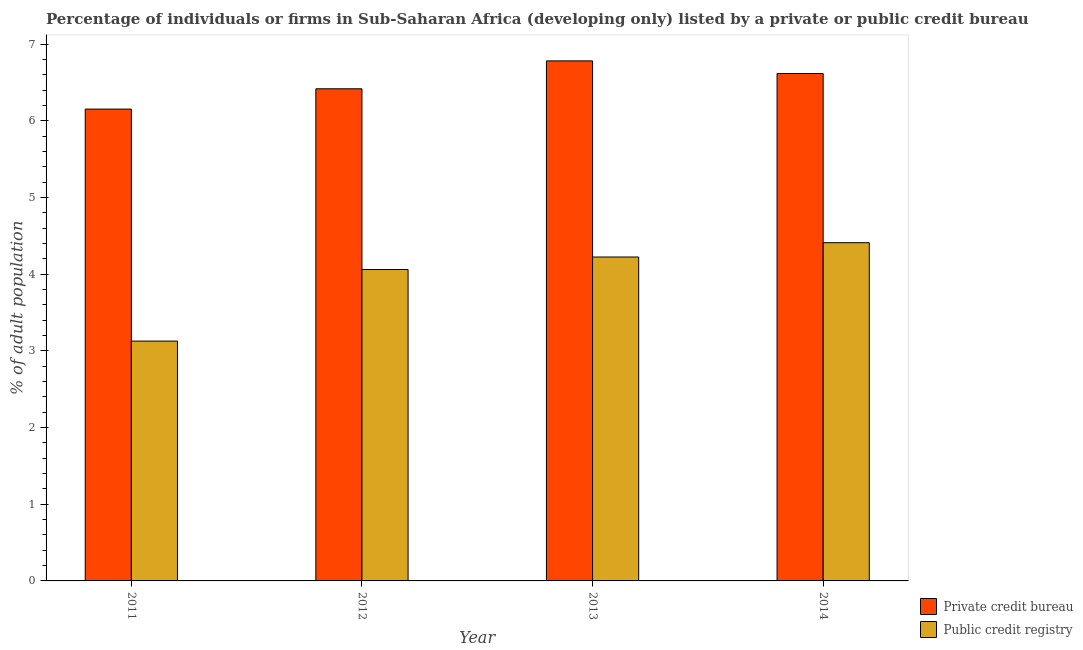Are the number of bars per tick equal to the number of legend labels?
Your response must be concise. Yes. How many bars are there on the 1st tick from the right?
Make the answer very short. 2. What is the label of the 4th group of bars from the left?
Ensure brevity in your answer.  2014. What is the percentage of firms listed by private credit bureau in 2013?
Provide a short and direct response. 6.78. Across all years, what is the maximum percentage of firms listed by public credit bureau?
Ensure brevity in your answer.  4.41. Across all years, what is the minimum percentage of firms listed by public credit bureau?
Provide a short and direct response. 3.13. What is the total percentage of firms listed by public credit bureau in the graph?
Your response must be concise. 15.82. What is the difference between the percentage of firms listed by private credit bureau in 2011 and that in 2014?
Keep it short and to the point. -0.46. What is the difference between the percentage of firms listed by private credit bureau in 2014 and the percentage of firms listed by public credit bureau in 2013?
Your answer should be compact. -0.16. What is the average percentage of firms listed by private credit bureau per year?
Offer a very short reply. 6.49. In the year 2014, what is the difference between the percentage of firms listed by public credit bureau and percentage of firms listed by private credit bureau?
Make the answer very short. 0. In how many years, is the percentage of firms listed by private credit bureau greater than 1 %?
Give a very brief answer. 4. What is the ratio of the percentage of firms listed by private credit bureau in 2013 to that in 2014?
Ensure brevity in your answer.  1.02. Is the difference between the percentage of firms listed by private credit bureau in 2011 and 2012 greater than the difference between the percentage of firms listed by public credit bureau in 2011 and 2012?
Your answer should be very brief. No. What is the difference between the highest and the second highest percentage of firms listed by private credit bureau?
Offer a very short reply. 0.16. What is the difference between the highest and the lowest percentage of firms listed by private credit bureau?
Give a very brief answer. 0.63. In how many years, is the percentage of firms listed by private credit bureau greater than the average percentage of firms listed by private credit bureau taken over all years?
Provide a short and direct response. 2. Is the sum of the percentage of firms listed by public credit bureau in 2013 and 2014 greater than the maximum percentage of firms listed by private credit bureau across all years?
Provide a short and direct response. Yes. What does the 1st bar from the left in 2011 represents?
Your response must be concise. Private credit bureau. What does the 2nd bar from the right in 2013 represents?
Keep it short and to the point. Private credit bureau. How many bars are there?
Your answer should be compact. 8. What is the difference between two consecutive major ticks on the Y-axis?
Your answer should be compact. 1. Are the values on the major ticks of Y-axis written in scientific E-notation?
Provide a short and direct response. No. Does the graph contain any zero values?
Make the answer very short. No. Does the graph contain grids?
Keep it short and to the point. No. Where does the legend appear in the graph?
Ensure brevity in your answer.  Bottom right. How many legend labels are there?
Provide a succinct answer. 2. How are the legend labels stacked?
Ensure brevity in your answer.  Vertical. What is the title of the graph?
Keep it short and to the point. Percentage of individuals or firms in Sub-Saharan Africa (developing only) listed by a private or public credit bureau. Does "Agricultural land" appear as one of the legend labels in the graph?
Make the answer very short. No. What is the label or title of the X-axis?
Offer a terse response. Year. What is the label or title of the Y-axis?
Your answer should be very brief. % of adult population. What is the % of adult population in Private credit bureau in 2011?
Provide a succinct answer. 6.15. What is the % of adult population in Public credit registry in 2011?
Give a very brief answer. 3.13. What is the % of adult population in Private credit bureau in 2012?
Offer a terse response. 6.42. What is the % of adult population of Public credit registry in 2012?
Provide a succinct answer. 4.06. What is the % of adult population in Private credit bureau in 2013?
Keep it short and to the point. 6.78. What is the % of adult population in Public credit registry in 2013?
Give a very brief answer. 4.22. What is the % of adult population in Private credit bureau in 2014?
Ensure brevity in your answer.  6.62. What is the % of adult population in Public credit registry in 2014?
Offer a terse response. 4.41. Across all years, what is the maximum % of adult population of Private credit bureau?
Your response must be concise. 6.78. Across all years, what is the maximum % of adult population of Public credit registry?
Your answer should be compact. 4.41. Across all years, what is the minimum % of adult population in Private credit bureau?
Keep it short and to the point. 6.15. Across all years, what is the minimum % of adult population in Public credit registry?
Your response must be concise. 3.13. What is the total % of adult population in Private credit bureau in the graph?
Offer a terse response. 25.97. What is the total % of adult population in Public credit registry in the graph?
Offer a very short reply. 15.82. What is the difference between the % of adult population in Private credit bureau in 2011 and that in 2012?
Offer a terse response. -0.26. What is the difference between the % of adult population in Public credit registry in 2011 and that in 2012?
Your response must be concise. -0.93. What is the difference between the % of adult population of Private credit bureau in 2011 and that in 2013?
Provide a succinct answer. -0.63. What is the difference between the % of adult population in Public credit registry in 2011 and that in 2013?
Provide a succinct answer. -1.1. What is the difference between the % of adult population of Private credit bureau in 2011 and that in 2014?
Offer a very short reply. -0.46. What is the difference between the % of adult population in Public credit registry in 2011 and that in 2014?
Give a very brief answer. -1.28. What is the difference between the % of adult population in Private credit bureau in 2012 and that in 2013?
Keep it short and to the point. -0.36. What is the difference between the % of adult population of Public credit registry in 2012 and that in 2013?
Provide a short and direct response. -0.16. What is the difference between the % of adult population of Private credit bureau in 2012 and that in 2014?
Your answer should be very brief. -0.2. What is the difference between the % of adult population in Public credit registry in 2012 and that in 2014?
Offer a terse response. -0.35. What is the difference between the % of adult population in Private credit bureau in 2013 and that in 2014?
Offer a terse response. 0.16. What is the difference between the % of adult population in Public credit registry in 2013 and that in 2014?
Your response must be concise. -0.19. What is the difference between the % of adult population in Private credit bureau in 2011 and the % of adult population in Public credit registry in 2012?
Your answer should be compact. 2.09. What is the difference between the % of adult population in Private credit bureau in 2011 and the % of adult population in Public credit registry in 2013?
Your answer should be very brief. 1.93. What is the difference between the % of adult population in Private credit bureau in 2011 and the % of adult population in Public credit registry in 2014?
Your answer should be compact. 1.74. What is the difference between the % of adult population in Private credit bureau in 2012 and the % of adult population in Public credit registry in 2013?
Your answer should be compact. 2.19. What is the difference between the % of adult population of Private credit bureau in 2012 and the % of adult population of Public credit registry in 2014?
Your answer should be very brief. 2.01. What is the difference between the % of adult population in Private credit bureau in 2013 and the % of adult population in Public credit registry in 2014?
Your answer should be very brief. 2.37. What is the average % of adult population of Private credit bureau per year?
Provide a short and direct response. 6.49. What is the average % of adult population in Public credit registry per year?
Keep it short and to the point. 3.96. In the year 2011, what is the difference between the % of adult population of Private credit bureau and % of adult population of Public credit registry?
Offer a very short reply. 3.03. In the year 2012, what is the difference between the % of adult population of Private credit bureau and % of adult population of Public credit registry?
Your response must be concise. 2.36. In the year 2013, what is the difference between the % of adult population in Private credit bureau and % of adult population in Public credit registry?
Give a very brief answer. 2.56. In the year 2014, what is the difference between the % of adult population of Private credit bureau and % of adult population of Public credit registry?
Ensure brevity in your answer.  2.21. What is the ratio of the % of adult population in Private credit bureau in 2011 to that in 2012?
Your answer should be compact. 0.96. What is the ratio of the % of adult population of Public credit registry in 2011 to that in 2012?
Ensure brevity in your answer.  0.77. What is the ratio of the % of adult population of Private credit bureau in 2011 to that in 2013?
Give a very brief answer. 0.91. What is the ratio of the % of adult population of Public credit registry in 2011 to that in 2013?
Make the answer very short. 0.74. What is the ratio of the % of adult population in Private credit bureau in 2011 to that in 2014?
Keep it short and to the point. 0.93. What is the ratio of the % of adult population in Public credit registry in 2011 to that in 2014?
Offer a very short reply. 0.71. What is the ratio of the % of adult population in Private credit bureau in 2012 to that in 2013?
Offer a very short reply. 0.95. What is the ratio of the % of adult population of Public credit registry in 2012 to that in 2013?
Offer a very short reply. 0.96. What is the ratio of the % of adult population of Private credit bureau in 2012 to that in 2014?
Your answer should be compact. 0.97. What is the ratio of the % of adult population of Public credit registry in 2012 to that in 2014?
Make the answer very short. 0.92. What is the ratio of the % of adult population in Private credit bureau in 2013 to that in 2014?
Your answer should be very brief. 1.02. What is the ratio of the % of adult population in Public credit registry in 2013 to that in 2014?
Provide a short and direct response. 0.96. What is the difference between the highest and the second highest % of adult population in Private credit bureau?
Keep it short and to the point. 0.16. What is the difference between the highest and the second highest % of adult population of Public credit registry?
Provide a succinct answer. 0.19. What is the difference between the highest and the lowest % of adult population of Private credit bureau?
Offer a very short reply. 0.63. What is the difference between the highest and the lowest % of adult population in Public credit registry?
Keep it short and to the point. 1.28. 